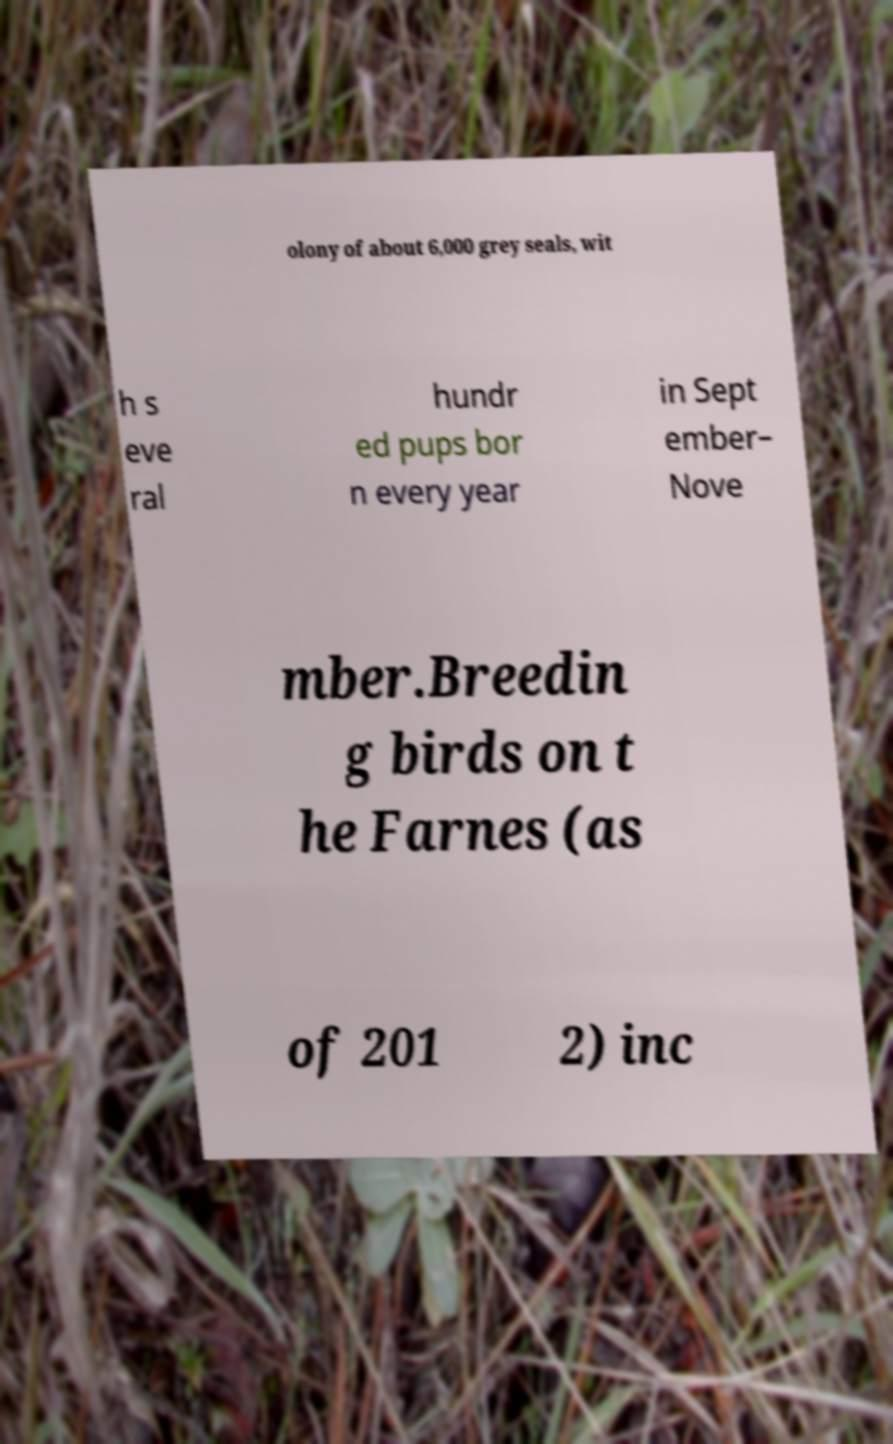I need the written content from this picture converted into text. Can you do that? olony of about 6,000 grey seals, wit h s eve ral hundr ed pups bor n every year in Sept ember– Nove mber.Breedin g birds on t he Farnes (as of 201 2) inc 